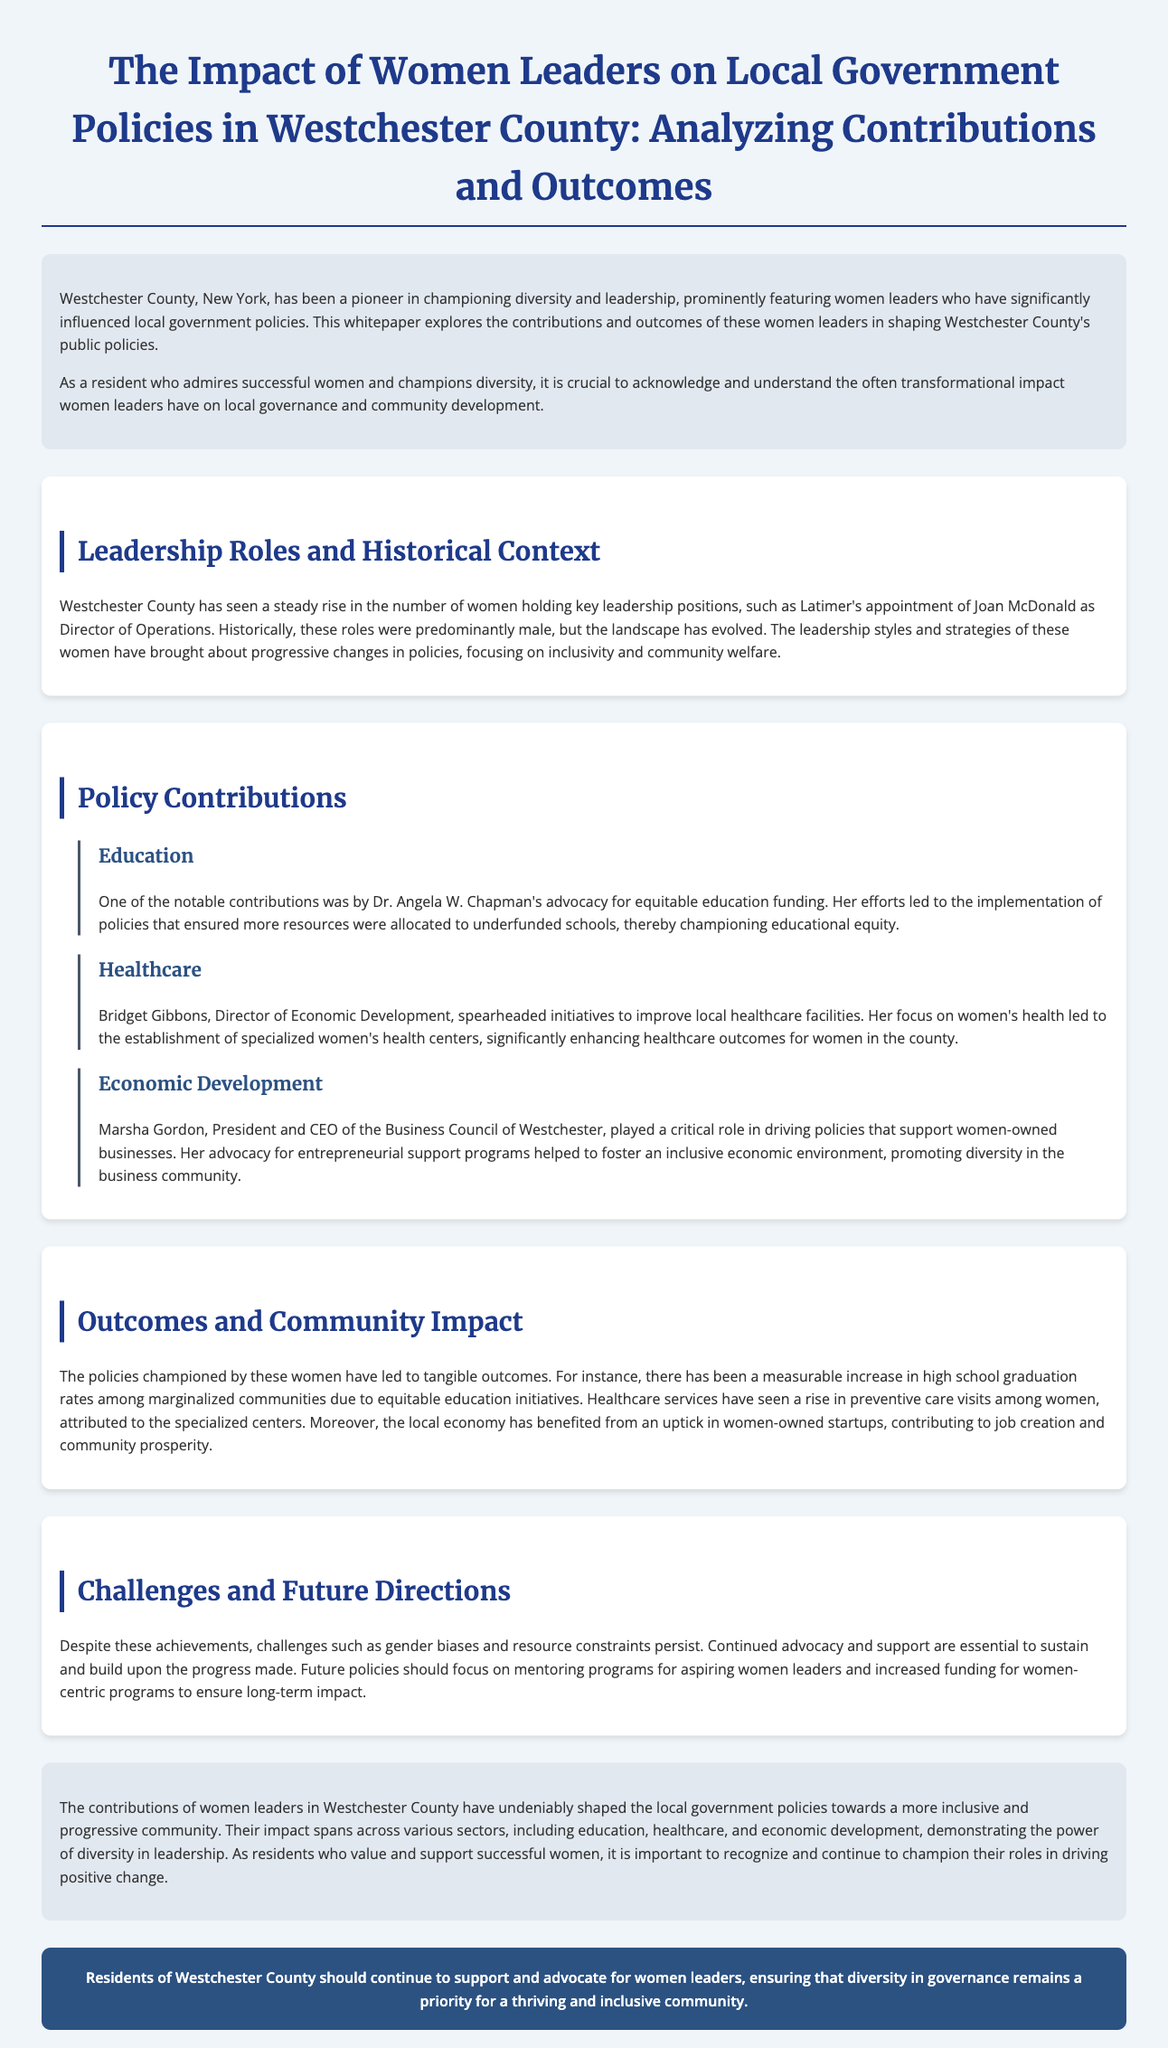What role did Joan McDonald hold? Joan McDonald was appointed as the Director of Operations, which is a leadership role mentioned in the document.
Answer: Director of Operations Who advocated for equitable education funding? The document states that Dr. Angela W. Chapman was known for her advocacy for equitable education funding.
Answer: Dr. Angela W. Chapman What impact did Bridget Gibbons have on healthcare? Bridget Gibbons led initiatives that resulted in the establishment of specialized women's health centers.
Answer: Specialized women's health centers In which area did Marsha Gordon focus her efforts? Marsha Gordon focused her efforts on supporting women-owned businesses as mentioned in her contributions.
Answer: Women-owned businesses What was a measurable outcome from the equitable education initiatives? The document notes that there was a measurable increase in high school graduation rates among marginalized communities.
Answer: High school graduation rates What challenge persists despite the achievements of women leaders? According to the document, gender biases persist as a challenge.
Answer: Gender biases What sector has benefited from an uptick in women-owned startups? The local economy benefited, as indicated in the outcomes section of the document.
Answer: Local economy What type of future policies does the document suggest? The document suggests future policies should focus on mentoring programs for aspiring women leaders.
Answer: Mentoring programs What is the call-to-action for residents of Westchester County? The call-to-action encourages residents to support and advocate for women leaders.
Answer: Support and advocate for women leaders 